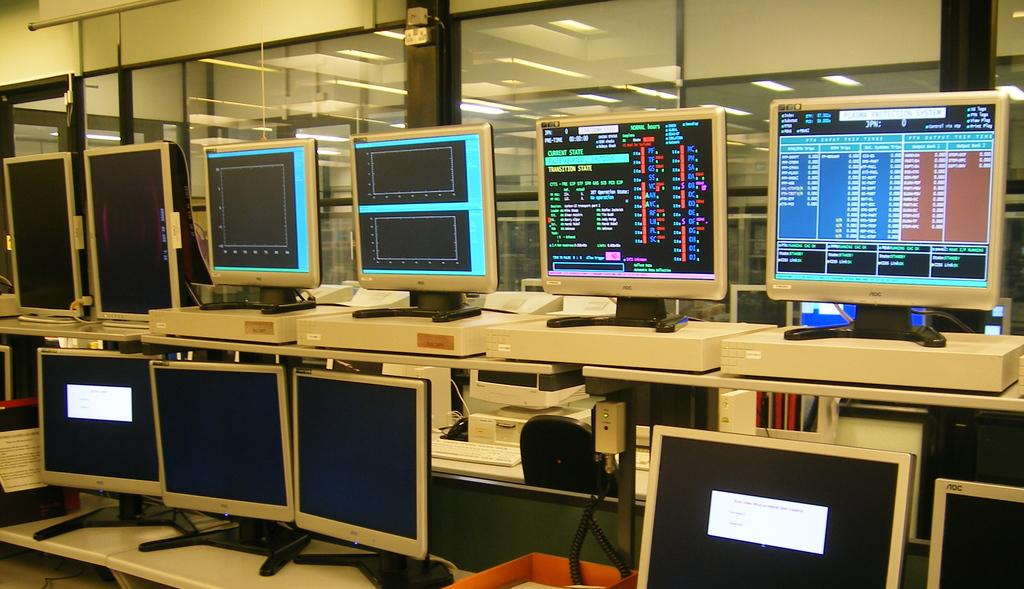What is the main subject of the image? The main subject of the image is many computers on a desk. What can be seen in the background of the image? In the background of the image, there is a wall and glass windows. What shape is the engine in the image? There is no engine present in the image. 